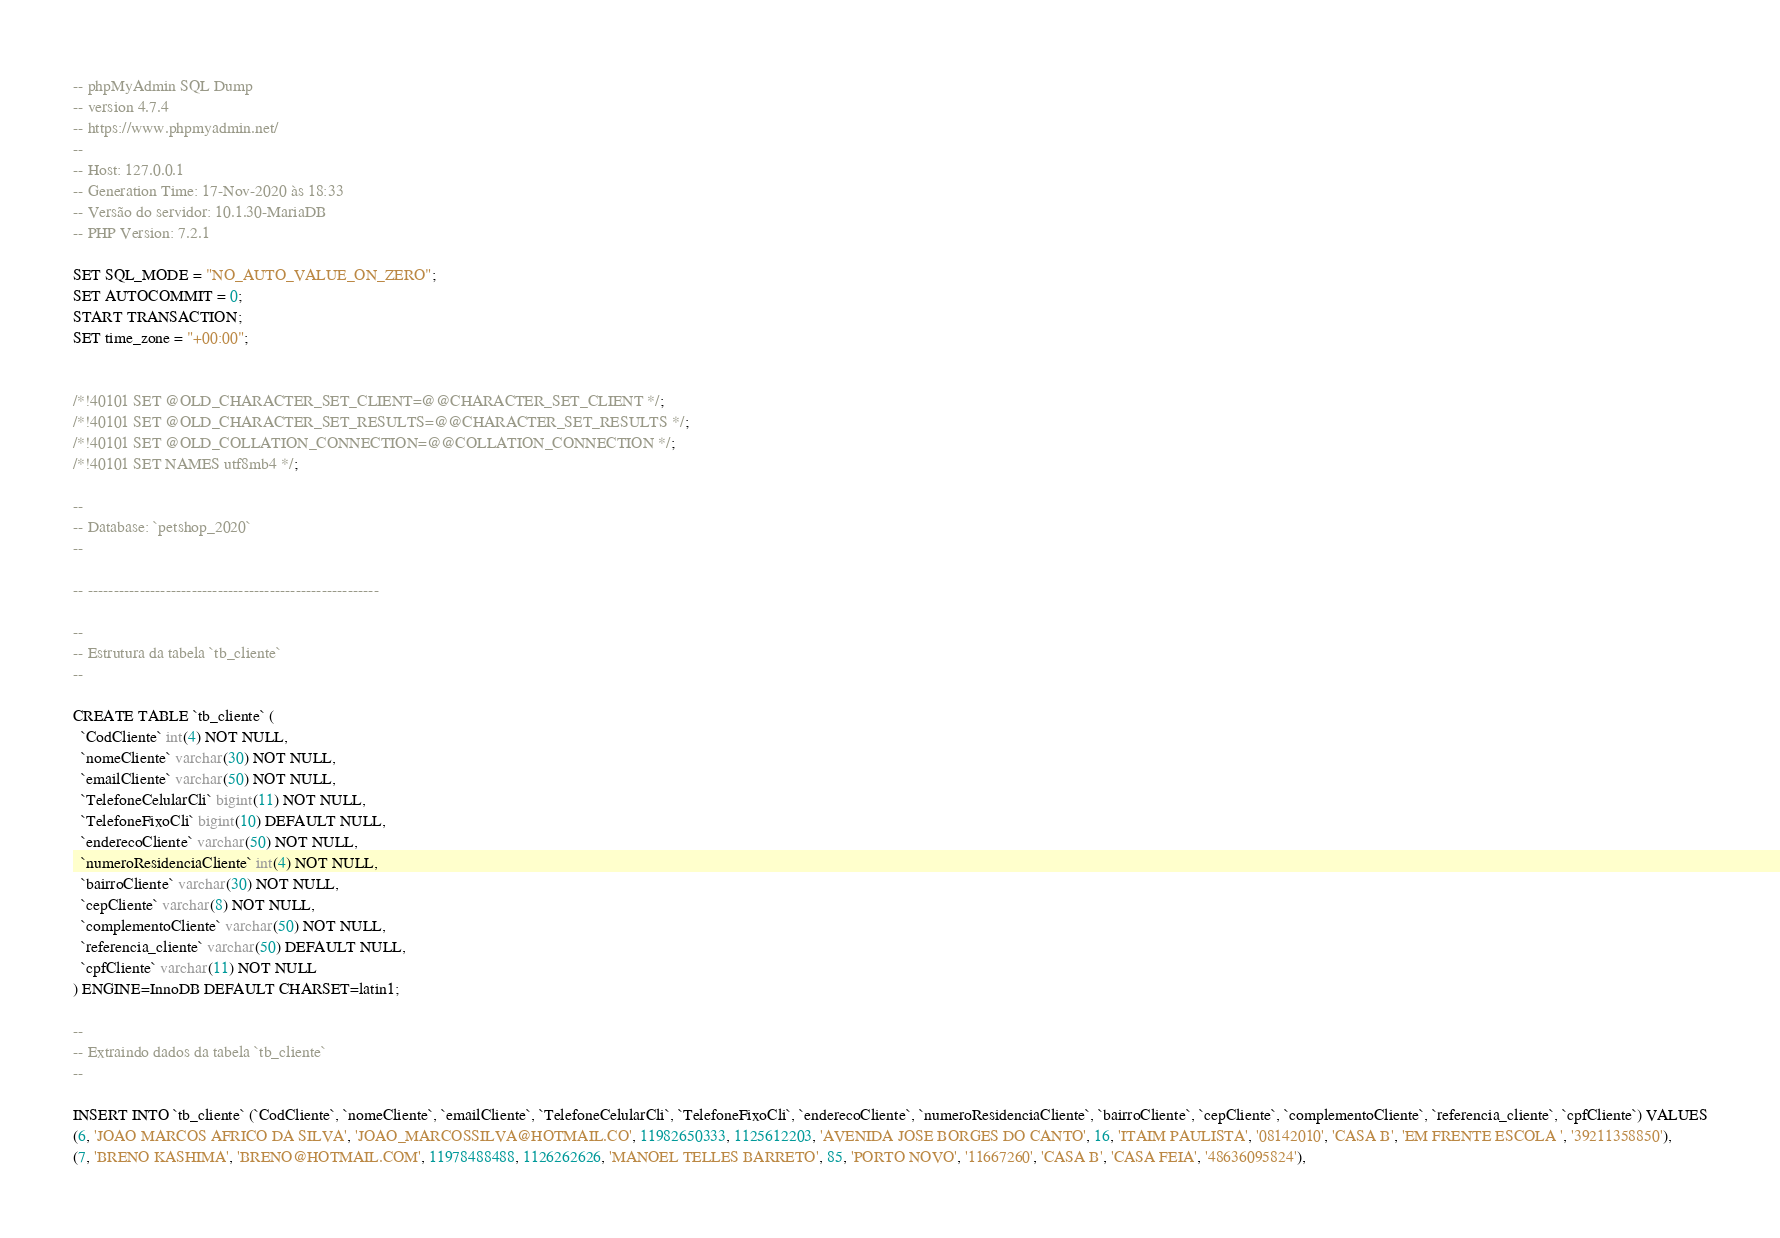<code> <loc_0><loc_0><loc_500><loc_500><_SQL_>-- phpMyAdmin SQL Dump
-- version 4.7.4
-- https://www.phpmyadmin.net/
--
-- Host: 127.0.0.1
-- Generation Time: 17-Nov-2020 às 18:33
-- Versão do servidor: 10.1.30-MariaDB
-- PHP Version: 7.2.1

SET SQL_MODE = "NO_AUTO_VALUE_ON_ZERO";
SET AUTOCOMMIT = 0;
START TRANSACTION;
SET time_zone = "+00:00";


/*!40101 SET @OLD_CHARACTER_SET_CLIENT=@@CHARACTER_SET_CLIENT */;
/*!40101 SET @OLD_CHARACTER_SET_RESULTS=@@CHARACTER_SET_RESULTS */;
/*!40101 SET @OLD_COLLATION_CONNECTION=@@COLLATION_CONNECTION */;
/*!40101 SET NAMES utf8mb4 */;

--
-- Database: `petshop_2020`
--

-- --------------------------------------------------------

--
-- Estrutura da tabela `tb_cliente`
--

CREATE TABLE `tb_cliente` (
  `CodCliente` int(4) NOT NULL,
  `nomeCliente` varchar(30) NOT NULL,
  `emailCliente` varchar(50) NOT NULL,
  `TelefoneCelularCli` bigint(11) NOT NULL,
  `TelefoneFixoCli` bigint(10) DEFAULT NULL,
  `enderecoCliente` varchar(50) NOT NULL,
  `numeroResidenciaCliente` int(4) NOT NULL,
  `bairroCliente` varchar(30) NOT NULL,
  `cepCliente` varchar(8) NOT NULL,
  `complementoCliente` varchar(50) NOT NULL,
  `referencia_cliente` varchar(50) DEFAULT NULL,
  `cpfCliente` varchar(11) NOT NULL
) ENGINE=InnoDB DEFAULT CHARSET=latin1;

--
-- Extraindo dados da tabela `tb_cliente`
--

INSERT INTO `tb_cliente` (`CodCliente`, `nomeCliente`, `emailCliente`, `TelefoneCelularCli`, `TelefoneFixoCli`, `enderecoCliente`, `numeroResidenciaCliente`, `bairroCliente`, `cepCliente`, `complementoCliente`, `referencia_cliente`, `cpfCliente`) VALUES
(6, 'JOAO MARCOS AFRICO DA SILVA', 'JOAO_MARCOSSILVA@HOTMAIL.CO', 11982650333, 1125612203, 'AVENIDA JOSE BORGES DO CANTO', 16, 'ITAIM PAULISTA', '08142010', 'CASA B', 'EM FRENTE ESCOLA ', '39211358850'),
(7, 'BRENO KASHIMA', 'BRENO@HOTMAIL.COM', 11978488488, 1126262626, 'MANOEL TELLES BARRETO', 85, 'PORTO NOVO', '11667260', 'CASA B', 'CASA FEIA', '48636095824'),</code> 